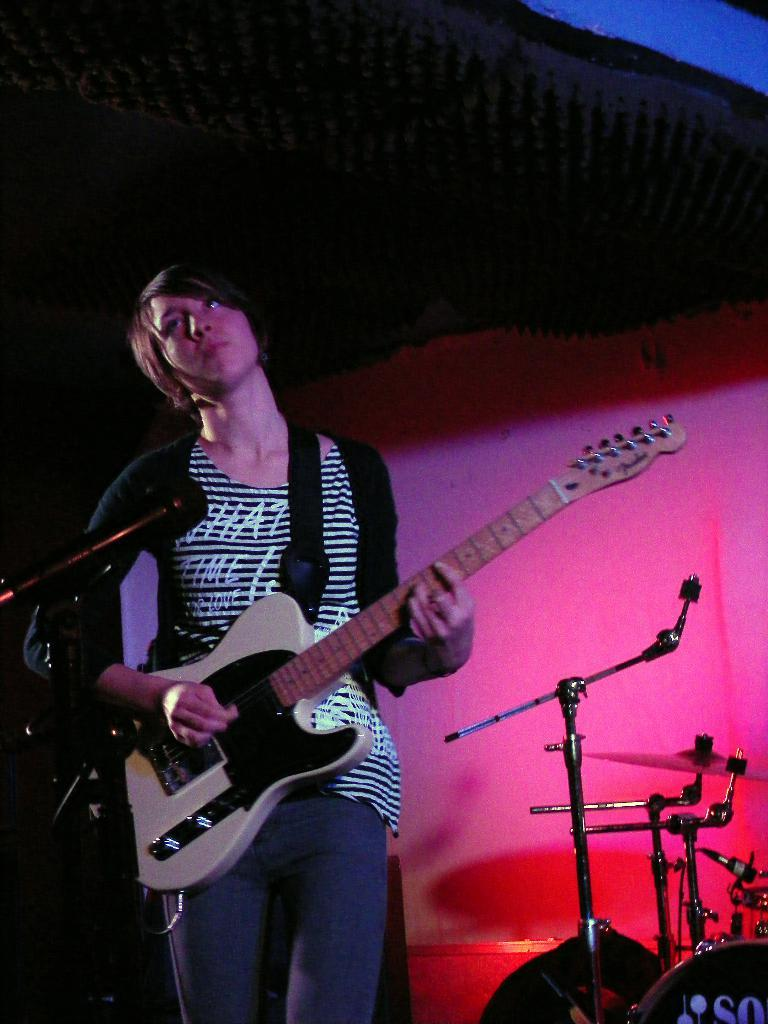What is the main subject of the image? There is a person in the image. What is the person wearing? The person is wearing clothes. What is the person doing in the image? The person is playing a guitar. What can be seen behind the person? The person is in front of a mic. What other musical instruments are visible in the image? There are musical instruments in the bottom right of the image. Reasoning: Let's think step by following the steps to produce the conversation. We start by identifying the main subject, which is the person in the image. Then, we describe the person's clothing and actions, which are playing a guitar and standing in front of a mic. Next, we mention the presence of other musical instruments in the image. Each question is designed to elicit a specific detail about the image that is known from the provided facts. Absurd Question/Answer: What type of knot is the person using to tune the guitar in the image? There is no indication in the image that the person is tuning the guitar, nor is there any mention of a knot. What type of invention can be seen in the person's hand while playing the guitar in the image? There is no invention visible in the person's hand while playing the guitar in the image. 